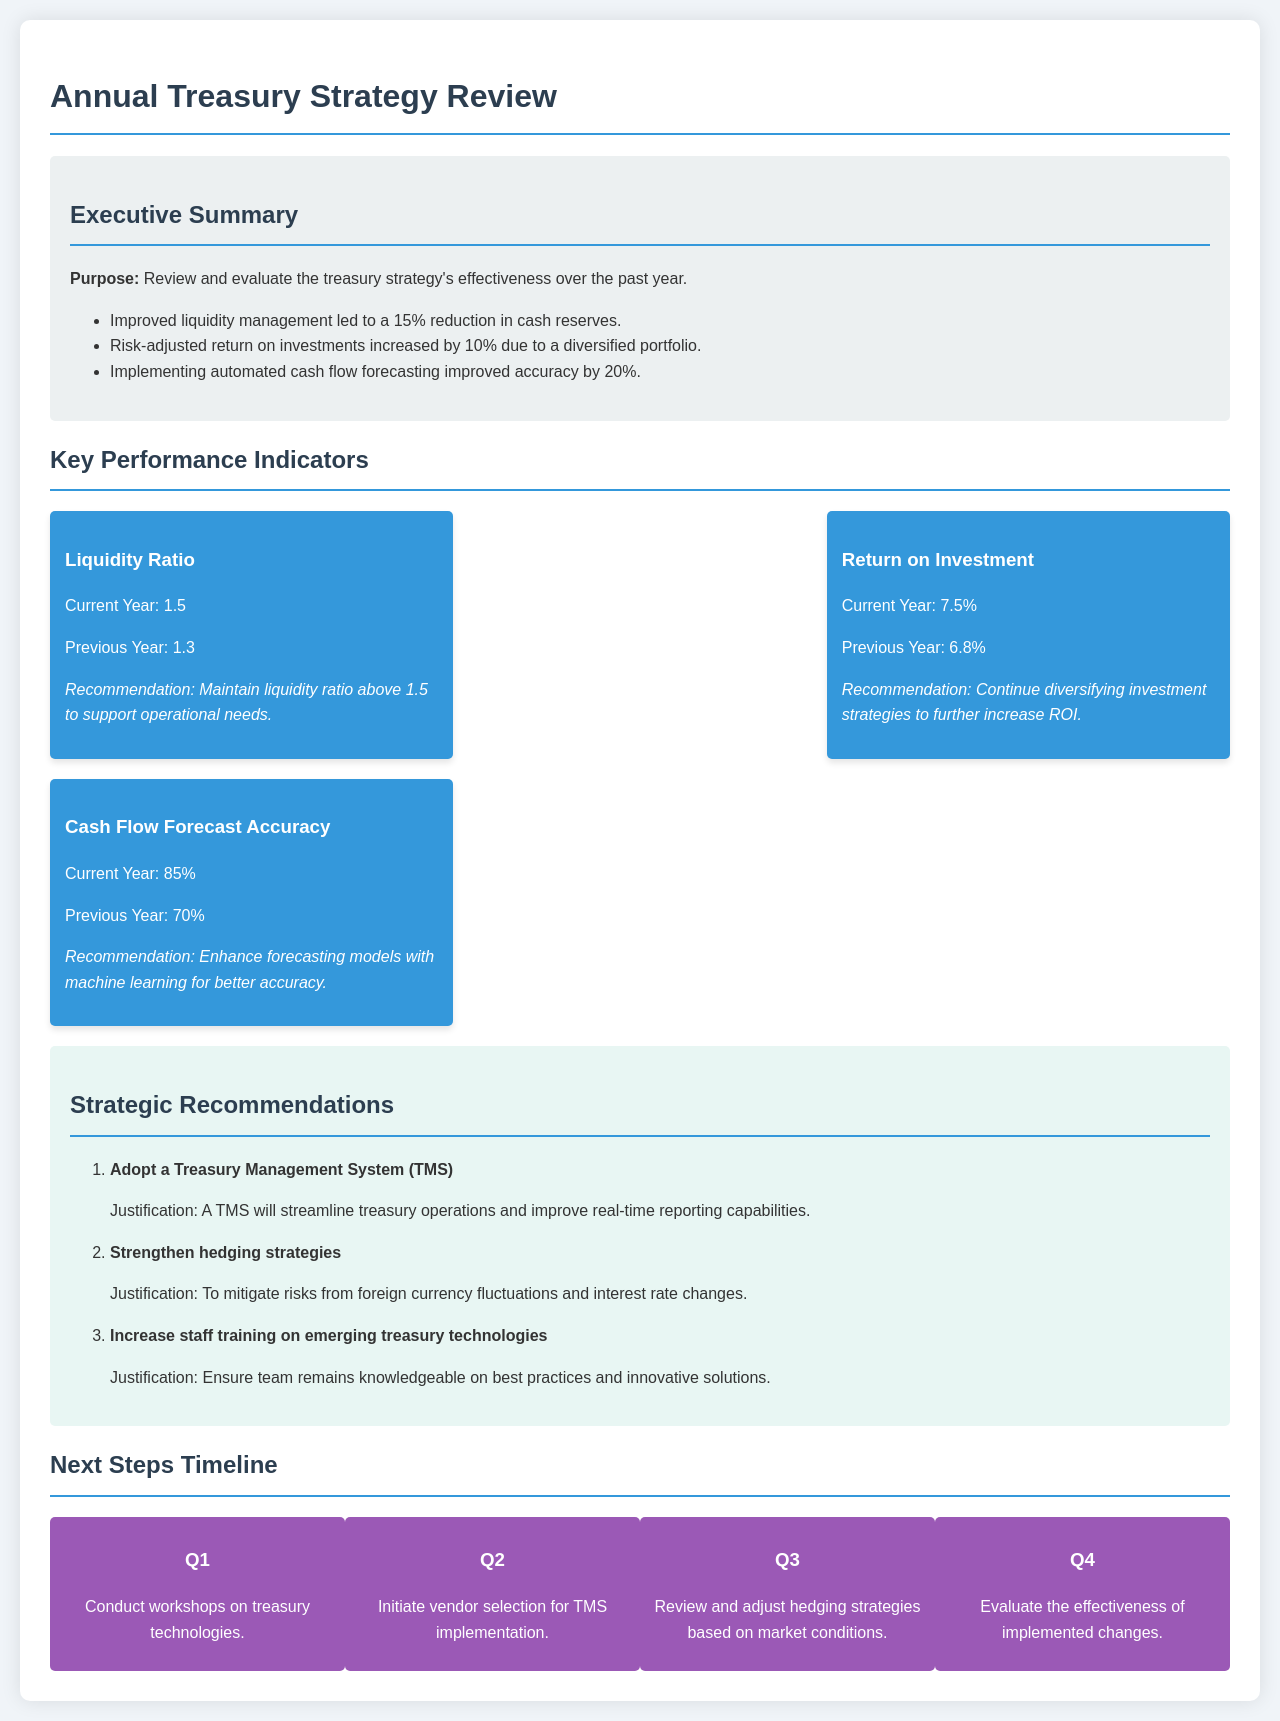What is the purpose of the review? The purpose is to review and evaluate the treasury strategy's effectiveness over the past year.
Answer: Review and evaluate the treasury strategy's effectiveness over the past year What was the reduction in cash reserves? The document states that improved liquidity management led to a 15% reduction in cash reserves.
Answer: 15% What is the current liquidity ratio? The current liquidity ratio is specifically mentioned in the document as 1.5.
Answer: 1.5 What is the recommendation for the return on investment? The recommendation is to continue diversifying investment strategies to further increase ROI.
Answer: Continue diversifying investment strategies to further increase ROI What is the cash flow forecast accuracy for the current year? According to the document, the cash flow forecast accuracy for the current year is 85%.
Answer: 85% What strategic recommendation targets currency fluctuations? The recommendation to strengthen hedging strategies is specifically aimed at mitigating risks from foreign currency fluctuations.
Answer: Strengthen hedging strategies What is scheduled for Q3? The document outlines that Q3 involves reviewing and adjusting hedging strategies based on market conditions.
Answer: Review and adjust hedging strategies based on market conditions How much did the risk-adjusted return on investments increase? The document specifies that risk-adjusted return on investments increased by 10%.
Answer: 10% What is the recommended action regarding staff training? The recommendation is to increase staff training on emerging treasury technologies to ensure knowledge of best practices.
Answer: Increase staff training on emerging treasury technologies 